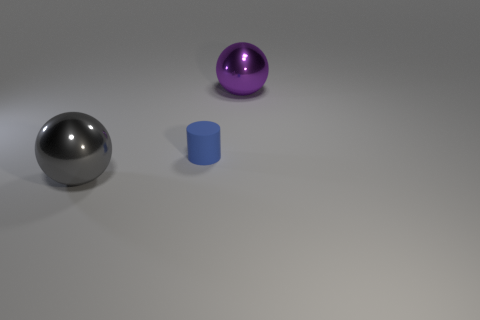Subtract all purple balls. How many balls are left? 1 Subtract all cylinders. How many objects are left? 2 Subtract 1 spheres. How many spheres are left? 1 Subtract all yellow cylinders. How many red spheres are left? 0 Subtract all large blue spheres. Subtract all small blue rubber cylinders. How many objects are left? 2 Add 1 big purple objects. How many big purple objects are left? 2 Add 2 large gray objects. How many large gray objects exist? 3 Add 1 purple spheres. How many objects exist? 4 Subtract 1 purple spheres. How many objects are left? 2 Subtract all gray spheres. Subtract all cyan cylinders. How many spheres are left? 1 